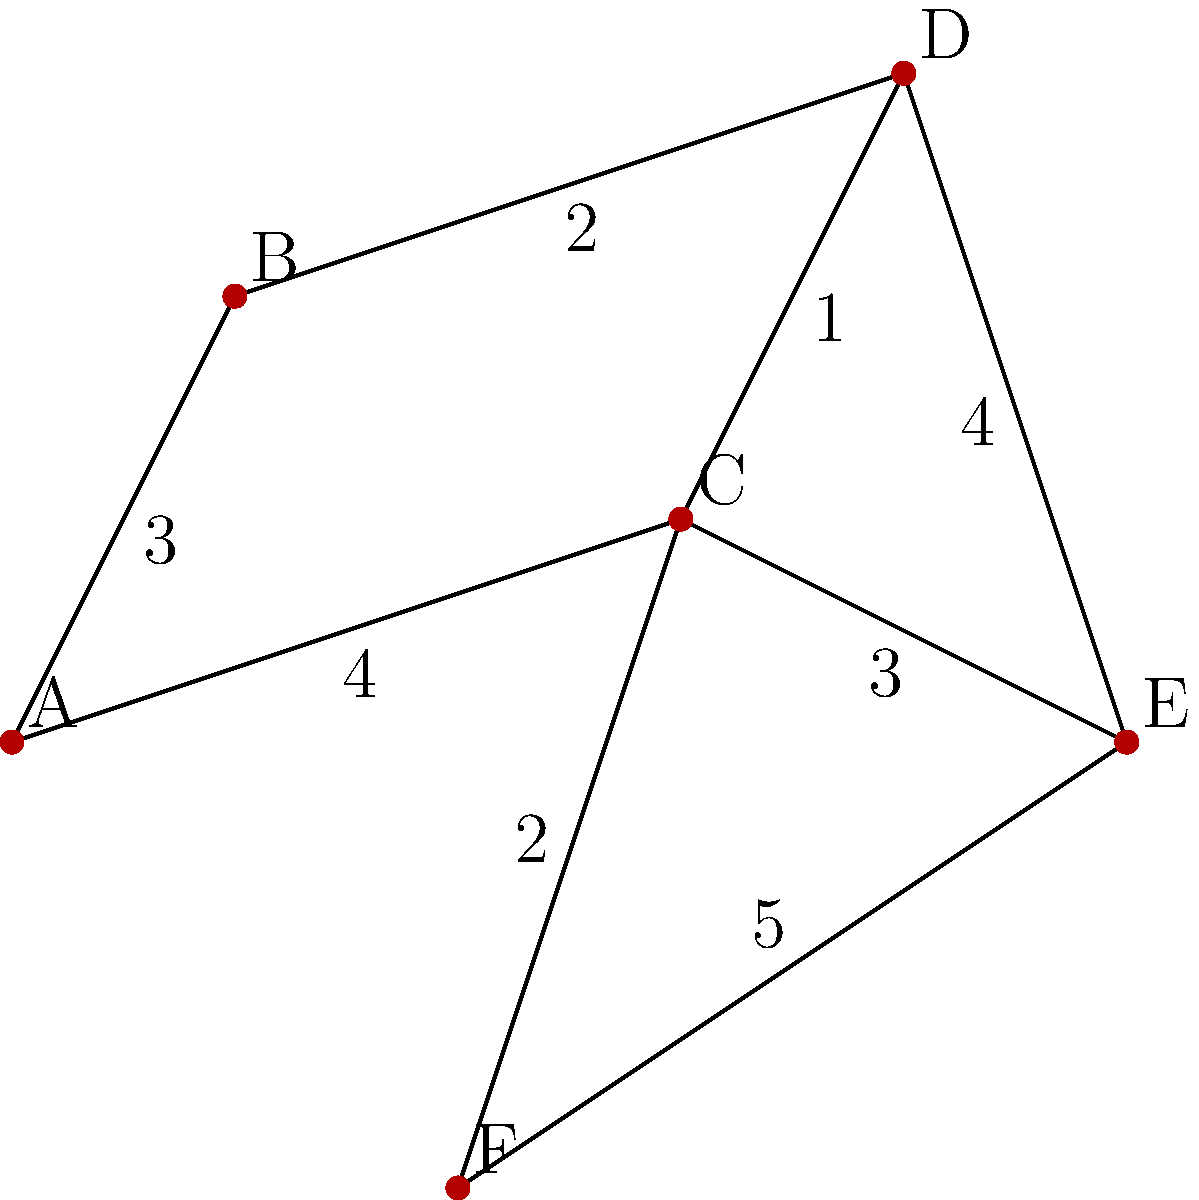Your grandfather, an Emory alumnus, fondly recalls his daily walks across campus. He challenges you to find the shortest path between the Alumni House (A) and the Emory Conference Center (E) on this simplified campus map. What is the length of the shortest path? To find the shortest path between A and E, we'll use Dijkstra's algorithm:

1. Initialize:
   - Distance to A = 0
   - Distance to all other vertices = infinity
   - Set of unvisited nodes = {A, B, C, D, E, F}

2. From A:
   - Update B: 0 + 3 = 3
   - Update C: 0 + 4 = 4
   - Mark A as visited

3. Select B (smallest distance):
   - Update D: 3 + 2 = 5
   - Mark B as visited

4. Select C:
   - Update D: min(5, 4 + 1) = 5
   - Update E: 4 + 3 = 7
   - Update F: 4 + 2 = 6
   - Mark C as visited

5. Select F:
   - Update E: min(7, 6 + 5) = 7
   - Mark F as visited

6. Select D:
   - Update E: min(7, 5 + 4) = 7
   - Mark D as visited

7. Select E:
   - Mark E as visited

The shortest path from A to E is A → C → E with a total length of 7.
Answer: 7 